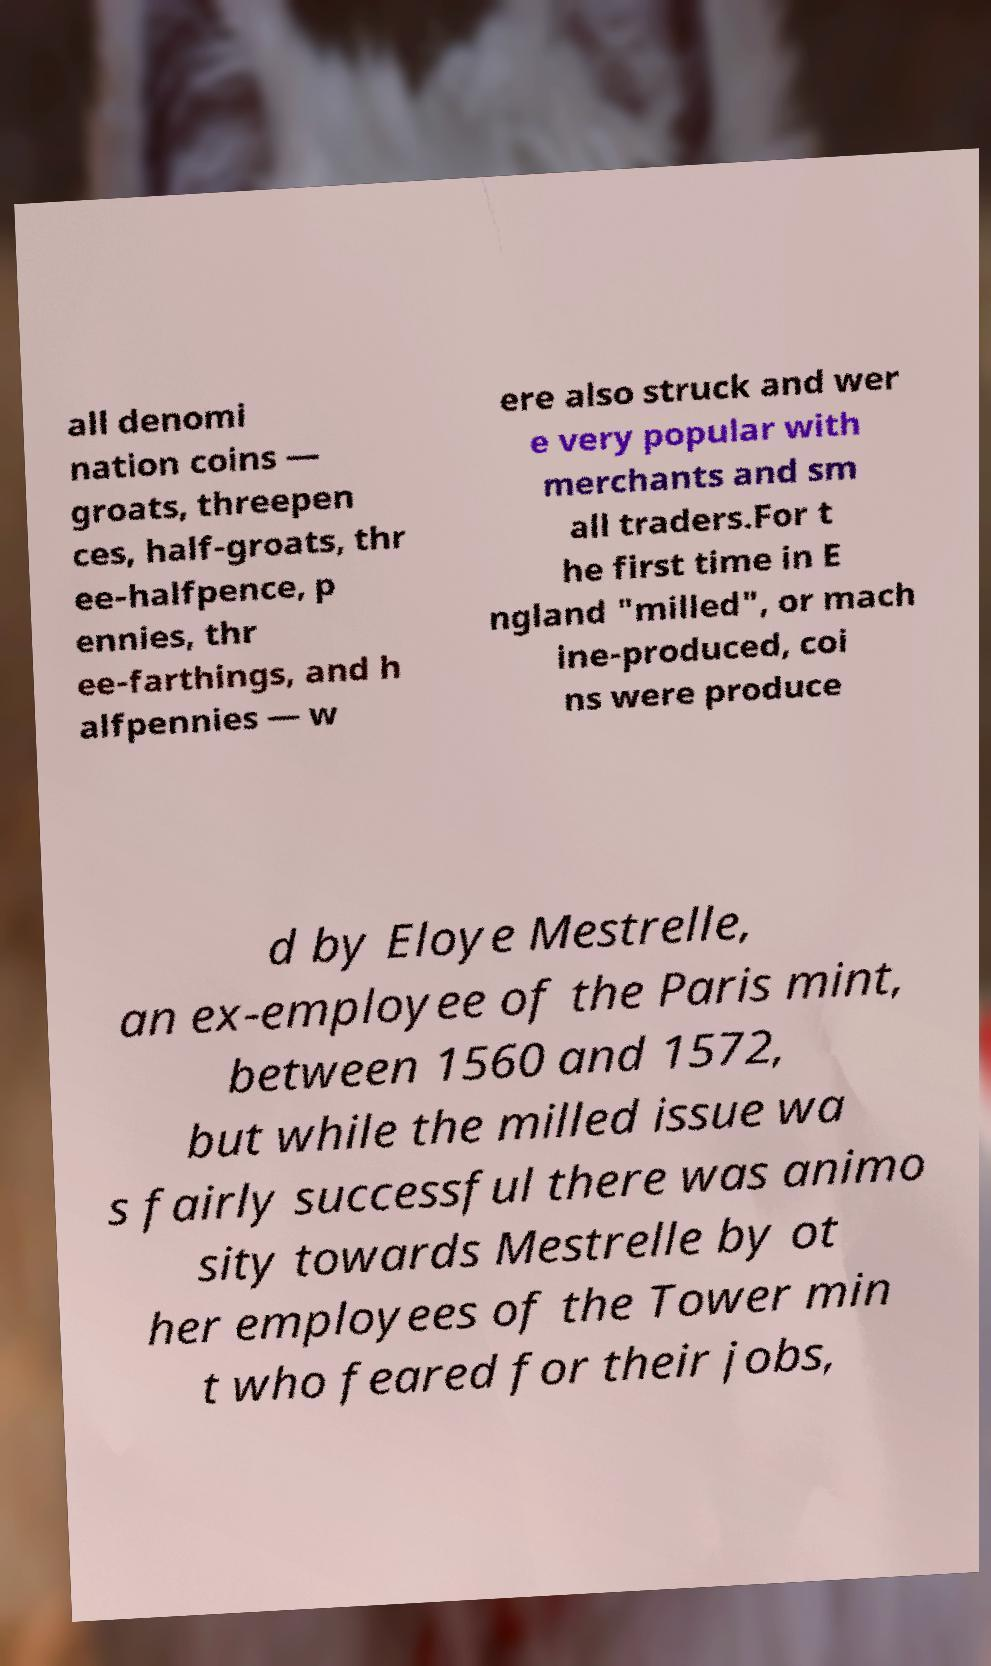For documentation purposes, I need the text within this image transcribed. Could you provide that? all denomi nation coins — groats, threepen ces, half-groats, thr ee-halfpence, p ennies, thr ee-farthings, and h alfpennies — w ere also struck and wer e very popular with merchants and sm all traders.For t he first time in E ngland "milled", or mach ine-produced, coi ns were produce d by Eloye Mestrelle, an ex-employee of the Paris mint, between 1560 and 1572, but while the milled issue wa s fairly successful there was animo sity towards Mestrelle by ot her employees of the Tower min t who feared for their jobs, 